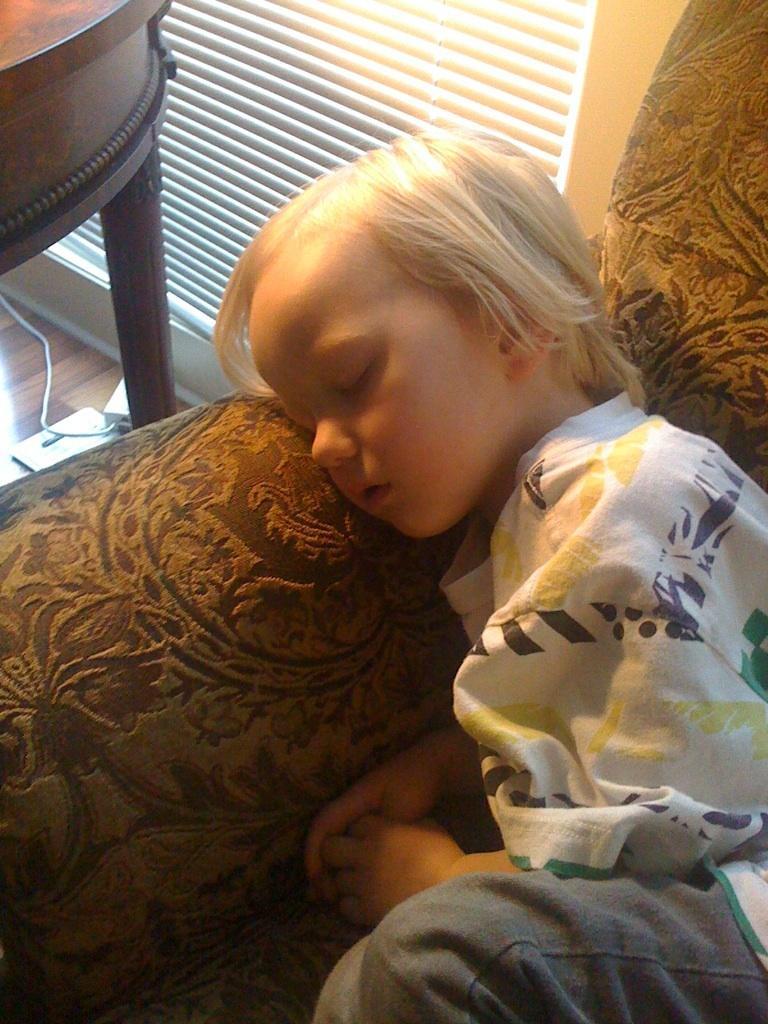In one or two sentences, can you explain what this image depicts? As we can see in the image there is a window blind, table, a boy wearing white color dress and sleeping on sofa. 